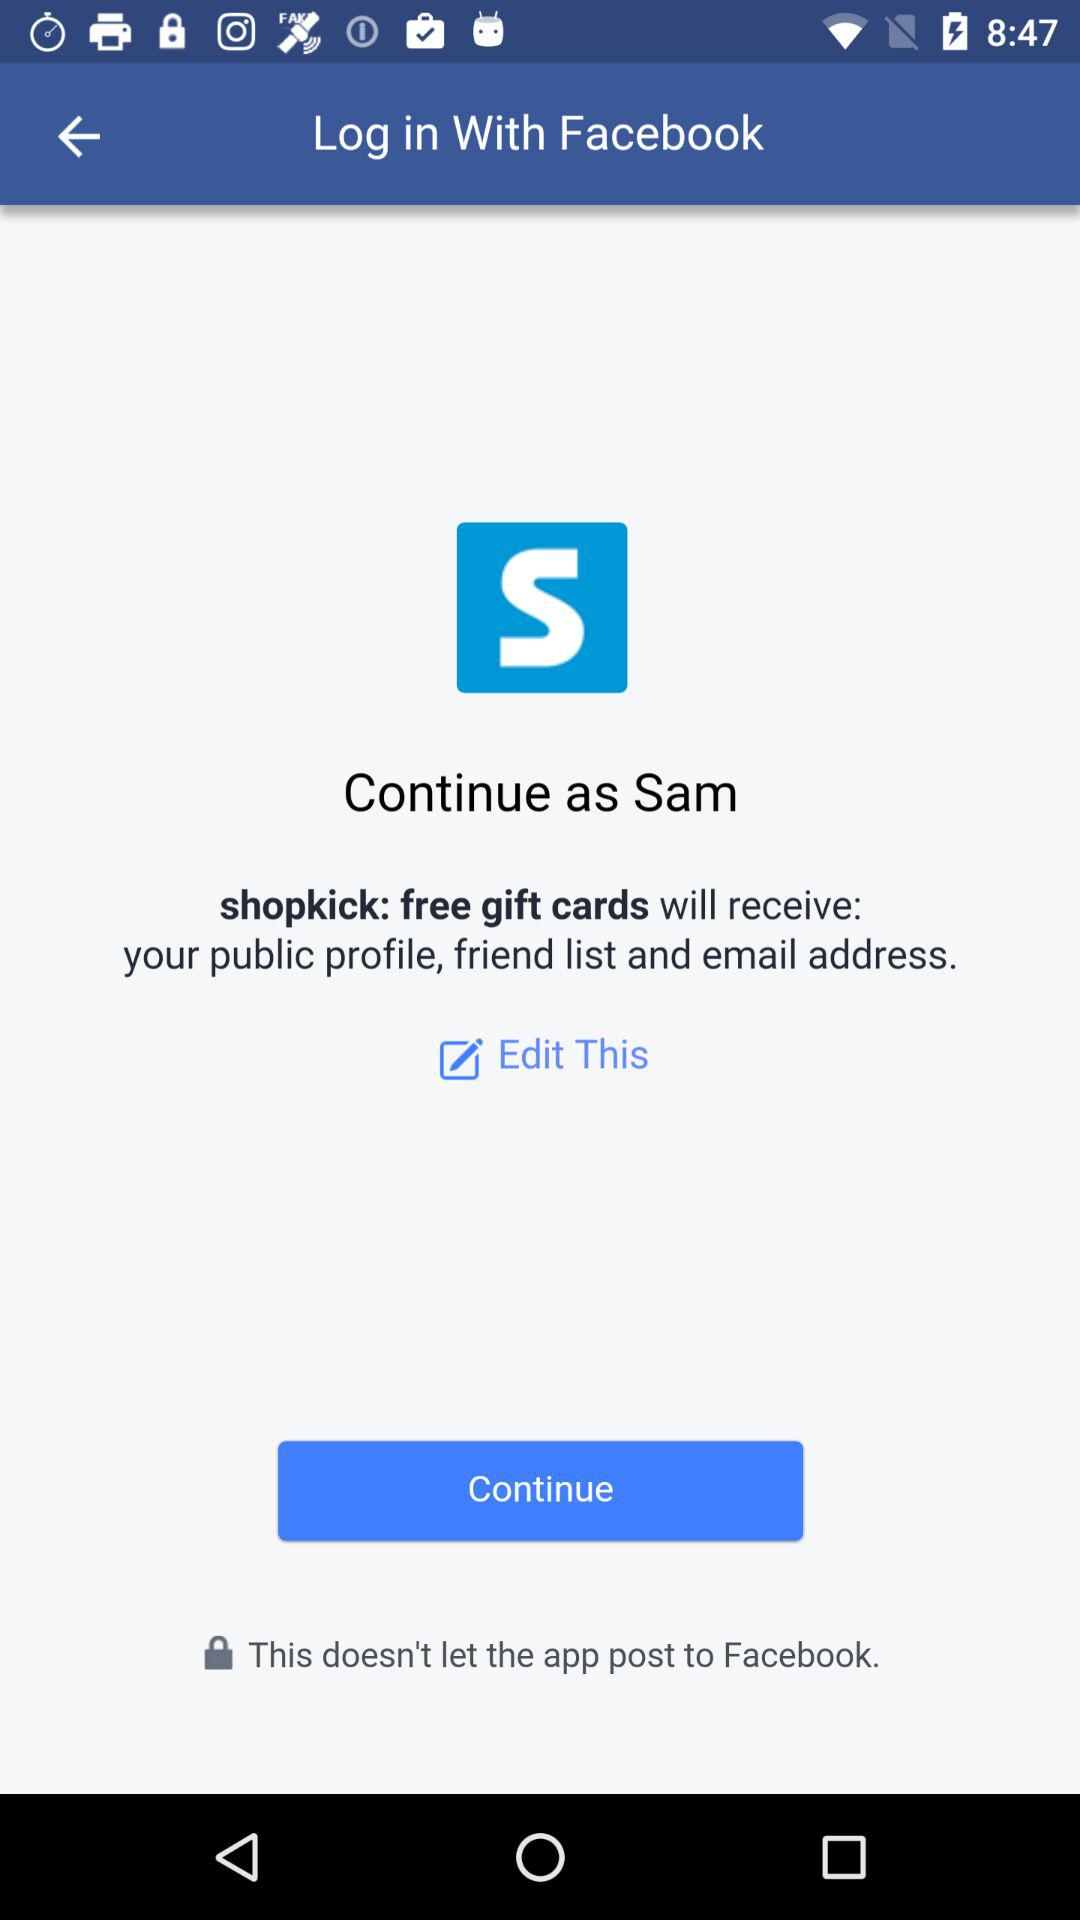What is the name of the user? The name of the user is Sam. 